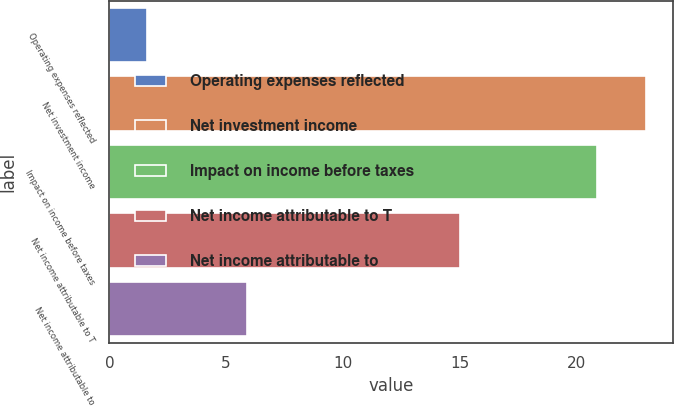Convert chart. <chart><loc_0><loc_0><loc_500><loc_500><bar_chart><fcel>Operating expenses reflected<fcel>Net investment income<fcel>Impact on income before taxes<fcel>Net income attributable to T<fcel>Net income attributable to<nl><fcel>1.6<fcel>22.99<fcel>20.9<fcel>15<fcel>5.9<nl></chart> 